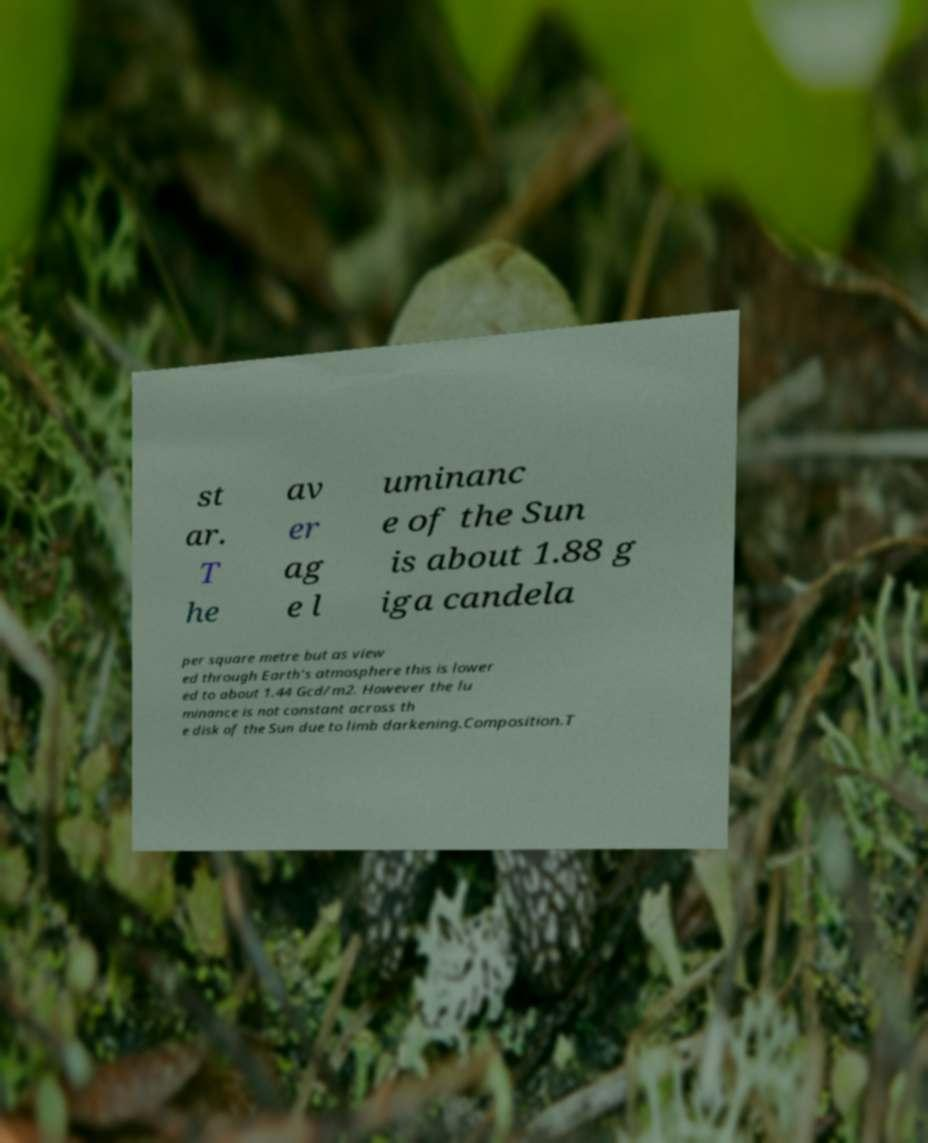For documentation purposes, I need the text within this image transcribed. Could you provide that? st ar. T he av er ag e l uminanc e of the Sun is about 1.88 g iga candela per square metre but as view ed through Earth's atmosphere this is lower ed to about 1.44 Gcd/m2. However the lu minance is not constant across th e disk of the Sun due to limb darkening.Composition.T 